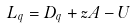<formula> <loc_0><loc_0><loc_500><loc_500>L _ { q } = D _ { q } + z A - U</formula> 